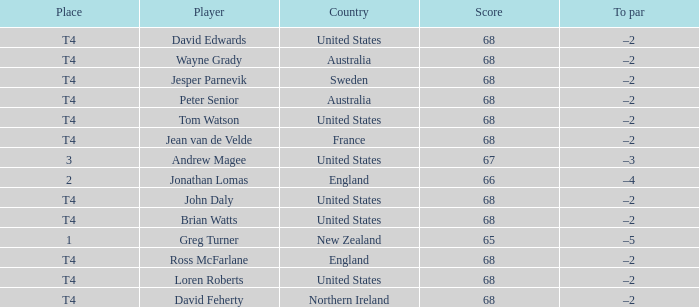Parse the table in full. {'header': ['Place', 'Player', 'Country', 'Score', 'To par'], 'rows': [['T4', 'David Edwards', 'United States', '68', '–2'], ['T4', 'Wayne Grady', 'Australia', '68', '–2'], ['T4', 'Jesper Parnevik', 'Sweden', '68', '–2'], ['T4', 'Peter Senior', 'Australia', '68', '–2'], ['T4', 'Tom Watson', 'United States', '68', '–2'], ['T4', 'Jean van de Velde', 'France', '68', '–2'], ['3', 'Andrew Magee', 'United States', '67', '–3'], ['2', 'Jonathan Lomas', 'England', '66', '–4'], ['T4', 'John Daly', 'United States', '68', '–2'], ['T4', 'Brian Watts', 'United States', '68', '–2'], ['1', 'Greg Turner', 'New Zealand', '65', '–5'], ['T4', 'Ross McFarlane', 'England', '68', '–2'], ['T4', 'Loren Roberts', 'United States', '68', '–2'], ['T4', 'David Feherty', 'Northern Ireland', '68', '–2']]} Who has a To par of –2, and a Country of united states? John Daly, David Edwards, Loren Roberts, Tom Watson, Brian Watts. 